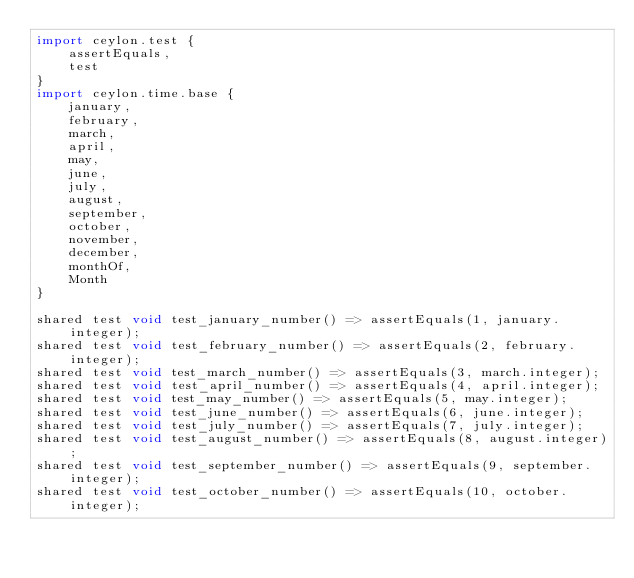<code> <loc_0><loc_0><loc_500><loc_500><_Ceylon_>import ceylon.test {
    assertEquals,
    test
}
import ceylon.time.base {
    january,
    february,
    march,
    april,
    may,
    june,
    july,
    august,
    september,
    october,
    november,
    december,
    monthOf,
    Month
}

shared test void test_january_number() => assertEquals(1, january.integer);
shared test void test_february_number() => assertEquals(2, february.integer);
shared test void test_march_number() => assertEquals(3, march.integer);
shared test void test_april_number() => assertEquals(4, april.integer);
shared test void test_may_number() => assertEquals(5, may.integer);
shared test void test_june_number() => assertEquals(6, june.integer);
shared test void test_july_number() => assertEquals(7, july.integer);
shared test void test_august_number() => assertEquals(8, august.integer);
shared test void test_september_number() => assertEquals(9, september.integer);
shared test void test_october_number() => assertEquals(10, october.integer);</code> 